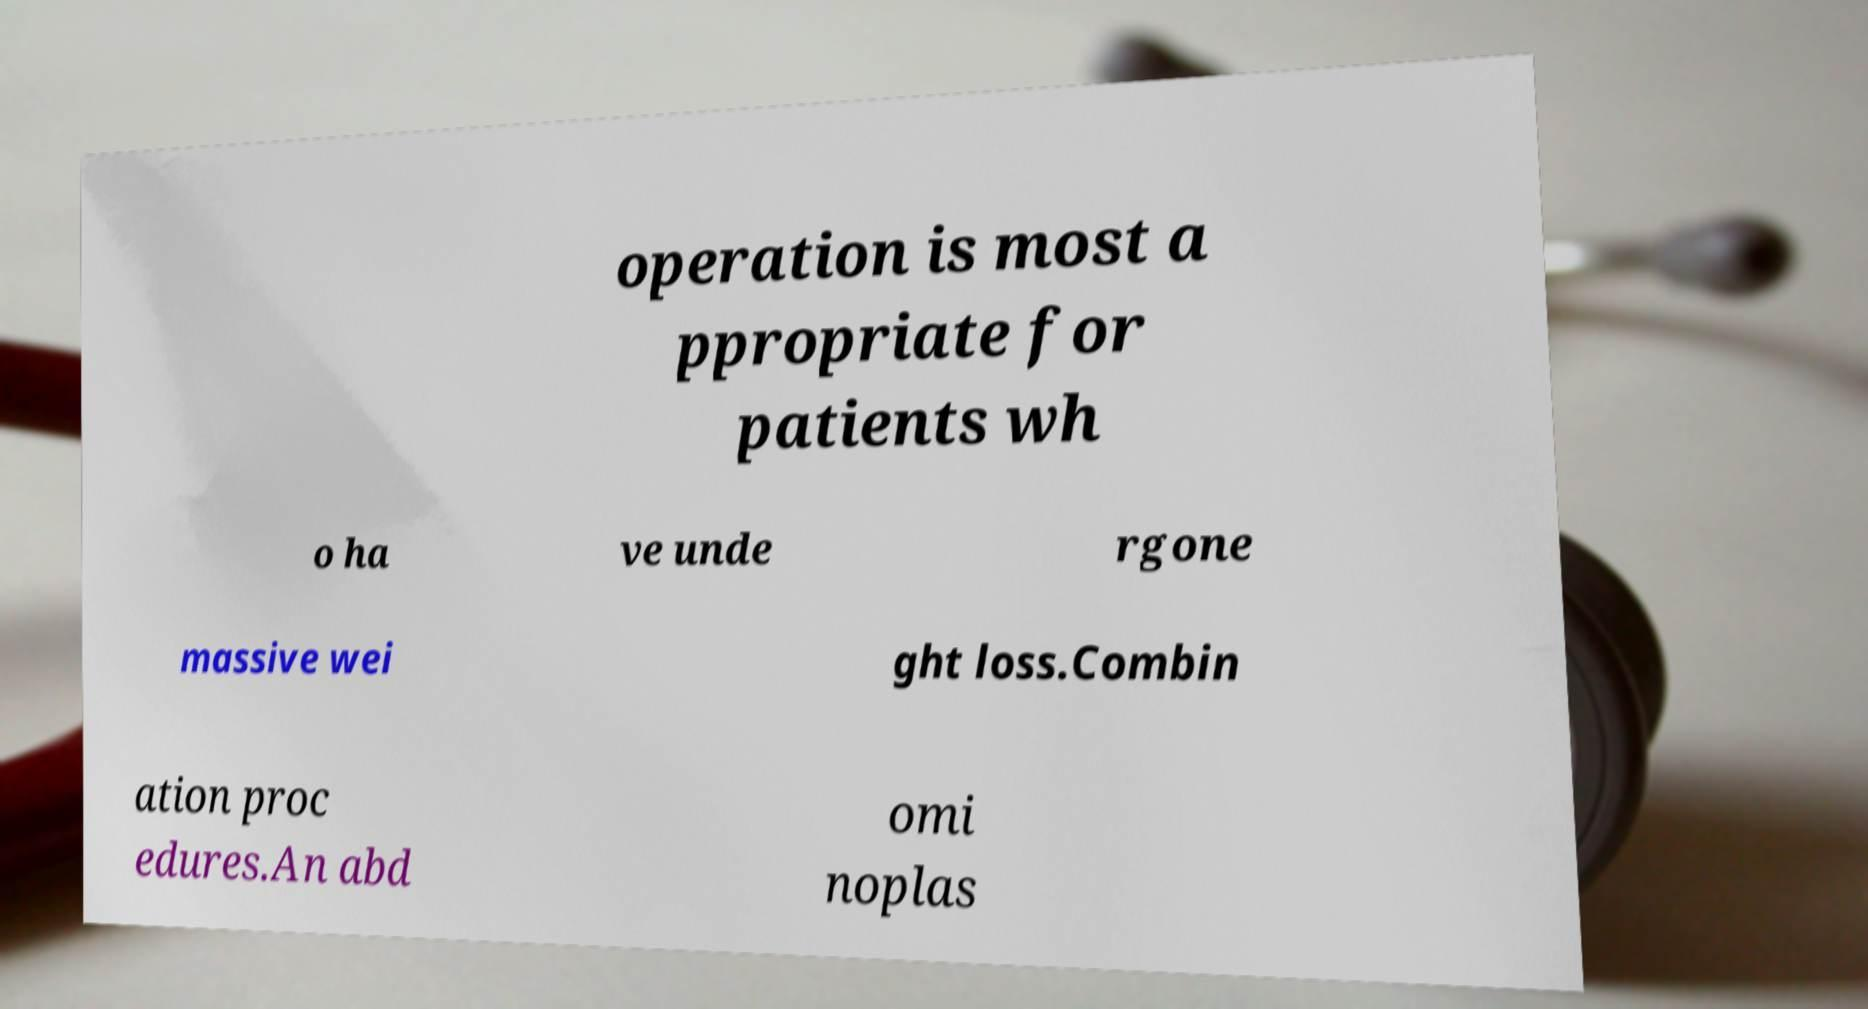Please identify and transcribe the text found in this image. operation is most a ppropriate for patients wh o ha ve unde rgone massive wei ght loss.Combin ation proc edures.An abd omi noplas 